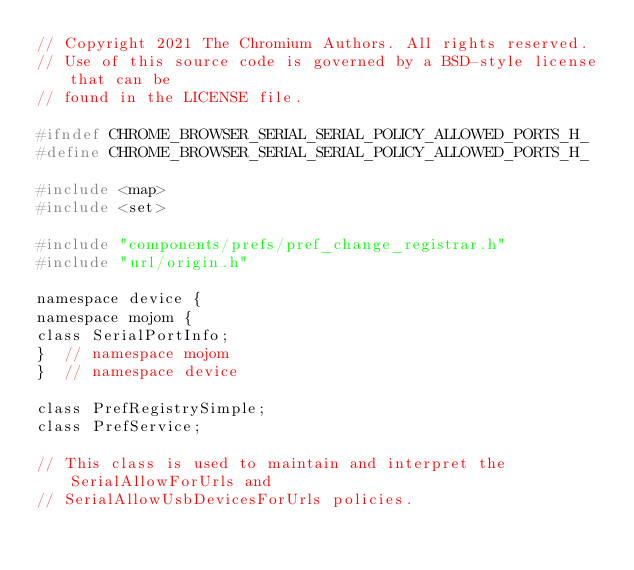<code> <loc_0><loc_0><loc_500><loc_500><_C_>// Copyright 2021 The Chromium Authors. All rights reserved.
// Use of this source code is governed by a BSD-style license that can be
// found in the LICENSE file.

#ifndef CHROME_BROWSER_SERIAL_SERIAL_POLICY_ALLOWED_PORTS_H_
#define CHROME_BROWSER_SERIAL_SERIAL_POLICY_ALLOWED_PORTS_H_

#include <map>
#include <set>

#include "components/prefs/pref_change_registrar.h"
#include "url/origin.h"

namespace device {
namespace mojom {
class SerialPortInfo;
}  // namespace mojom
}  // namespace device

class PrefRegistrySimple;
class PrefService;

// This class is used to maintain and interpret the SerialAllowForUrls and
// SerialAllowUsbDevicesForUrls policies.</code> 